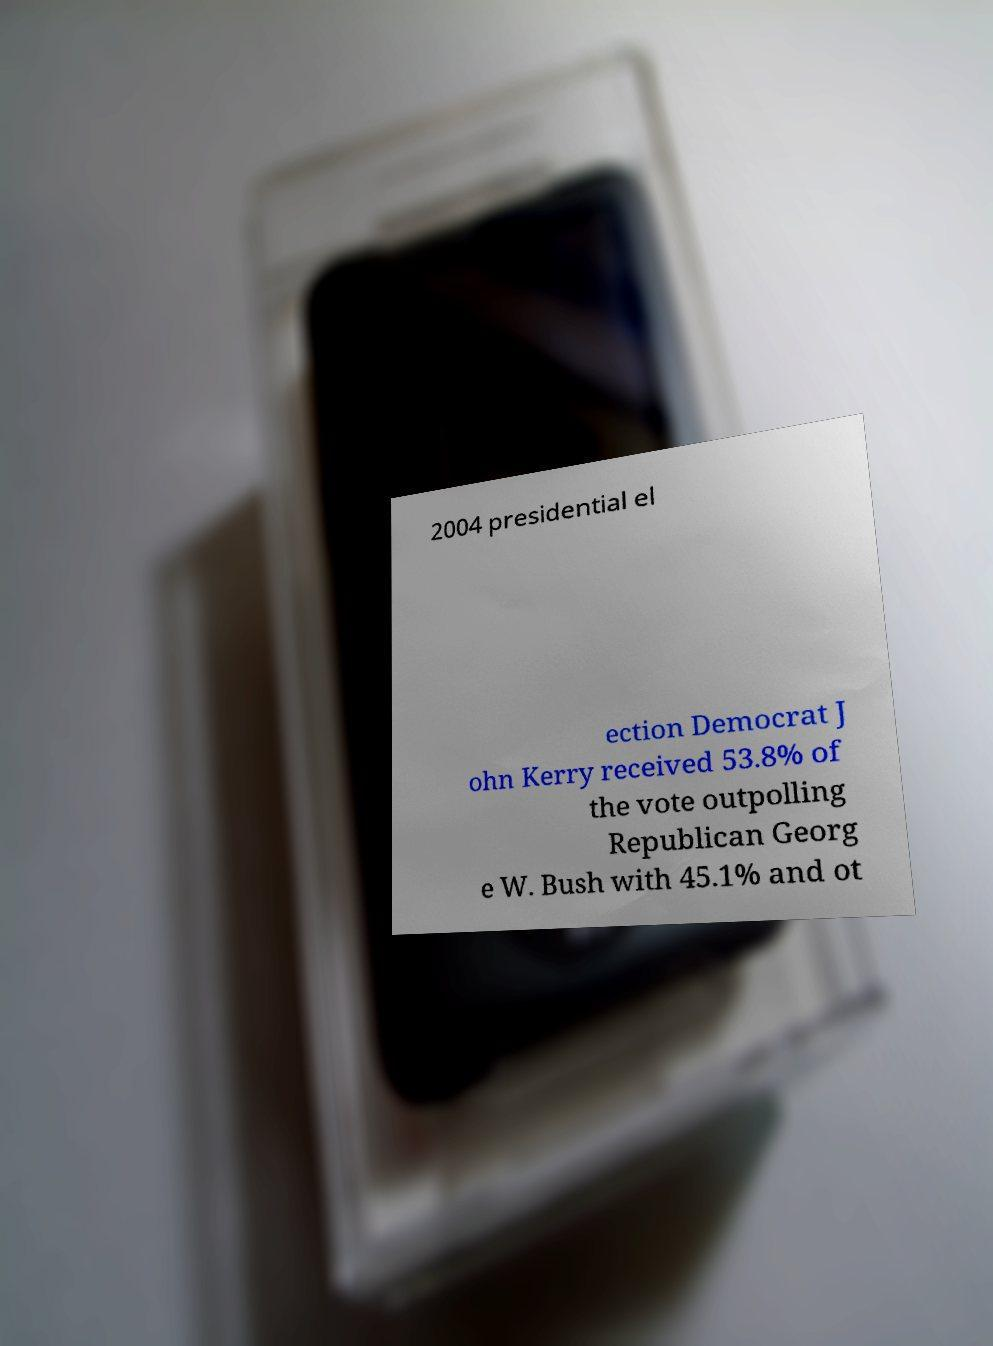Please identify and transcribe the text found in this image. 2004 presidential el ection Democrat J ohn Kerry received 53.8% of the vote outpolling Republican Georg e W. Bush with 45.1% and ot 